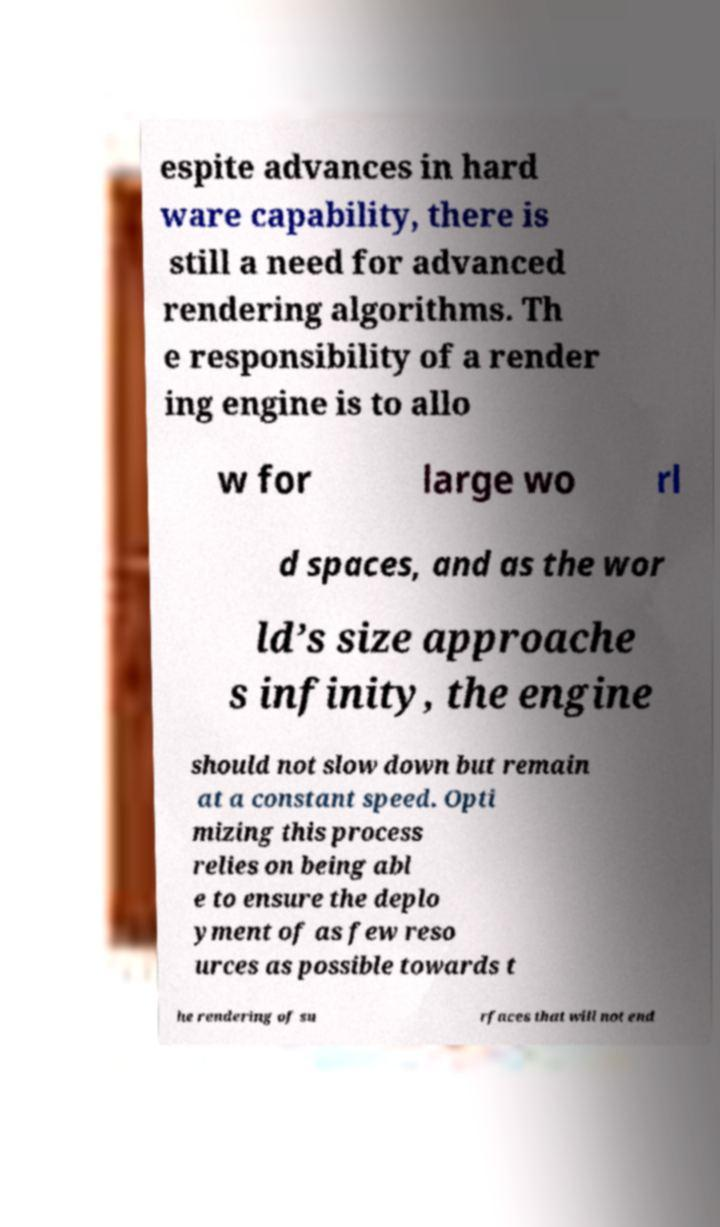Please read and relay the text visible in this image. What does it say? espite advances in hard ware capability, there is still a need for advanced rendering algorithms. Th e responsibility of a render ing engine is to allo w for large wo rl d spaces, and as the wor ld’s size approache s infinity, the engine should not slow down but remain at a constant speed. Opti mizing this process relies on being abl e to ensure the deplo yment of as few reso urces as possible towards t he rendering of su rfaces that will not end 